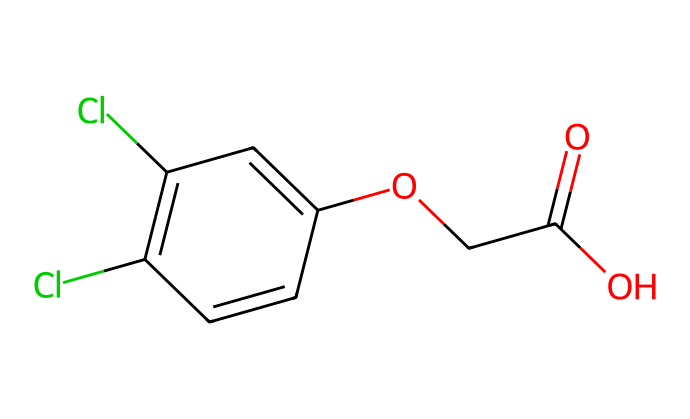What is the molecular formula of 2,4-D? By analyzing the SMILES representation, we can break down the components: the presence of two chlorine atoms (Cl), one phenoxy group (-OCC(=O)O), and five carbon atoms gives us the backbone. Counting them provides us with C8H6Cl2O3.
Answer: C8H6Cl2O3 How many chlorine atoms are present in the structure? The SMILES representation indicates "Cl" appears twice, meaning there are two chlorine atoms in the molecular structure.
Answer: 2 What functional groups are present in 2,4-D? The chemical contains a carboxylic acid group (-COOH), as indicated by "C(=O)O", and an ether group (-O-), represented by "-OCC". This identifies the relevant functional groups.
Answer: carboxylic acid and ether What is the significance of the molecules' chlorine content in herbicides? Chlorine content in herbicides, particularly in 2,4-D, enhances its bioactivity and helps in targeting specific plant pathways while reducing growth in unwanted species.
Answer: enhances bioactivity How does the phenoxy group affect the herbicide's activity? The presence of the phenoxy group is crucial for mimicking plant growth hormones, specifically auxins, which allows for selective herbicide action that disrupts growth in target plants.
Answer: mimics plant hormones What is the number of double bonds in the structure? By examining the SMILES, we find two double bonds indicated by the "=" symbol in the aromatic ring, confirming the presence of two double bonds in the structure.
Answer: 2 What role does the hydroxy group (–OH) play in this herbicide? The hydroxy group can influence the chemical's solubility and reactivity, enhancing its efficiency and selectivity in controlling broadleaf weeds in crops.
Answer: enhances solubility and reactivity 